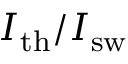Convert formula to latex. <formula><loc_0><loc_0><loc_500><loc_500>I _ { t h } / I _ { s w }</formula> 